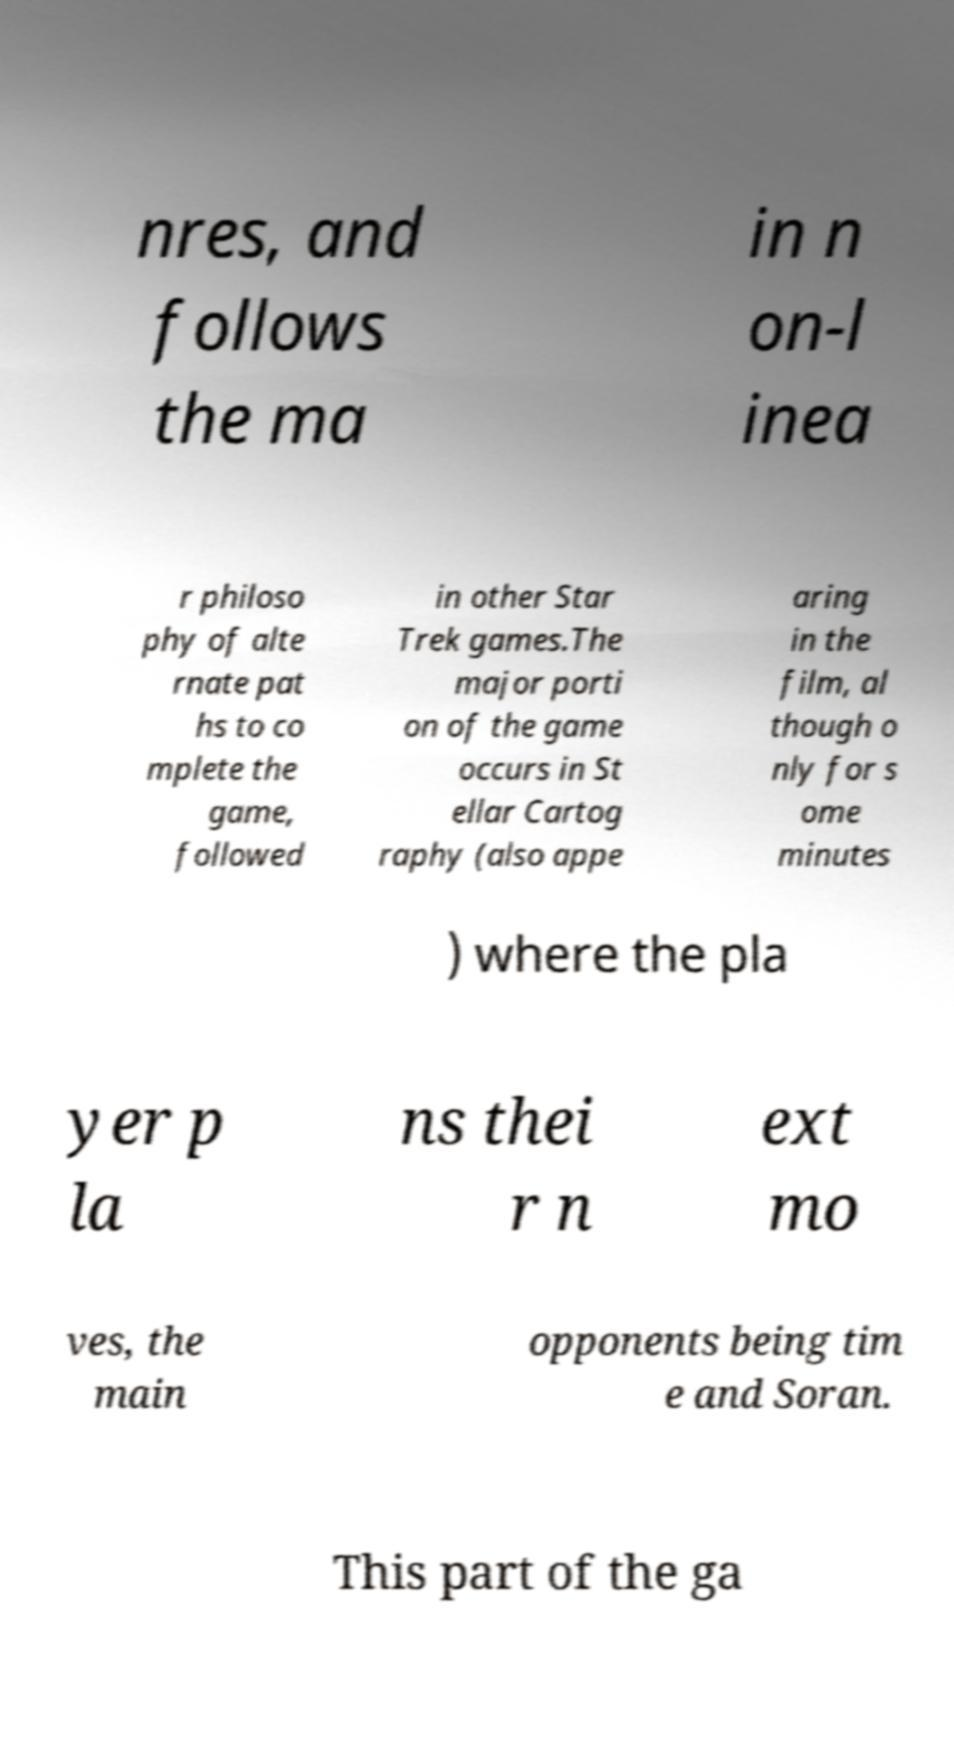Please read and relay the text visible in this image. What does it say? nres, and follows the ma in n on-l inea r philoso phy of alte rnate pat hs to co mplete the game, followed in other Star Trek games.The major porti on of the game occurs in St ellar Cartog raphy (also appe aring in the film, al though o nly for s ome minutes ) where the pla yer p la ns thei r n ext mo ves, the main opponents being tim e and Soran. This part of the ga 